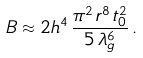Convert formula to latex. <formula><loc_0><loc_0><loc_500><loc_500>B \approx 2 h ^ { 4 } \, \frac { \pi ^ { 2 } \, r ^ { 8 } \, t _ { 0 } ^ { 2 } } { 5 \, \lambda _ { g } ^ { 6 } } \, .</formula> 